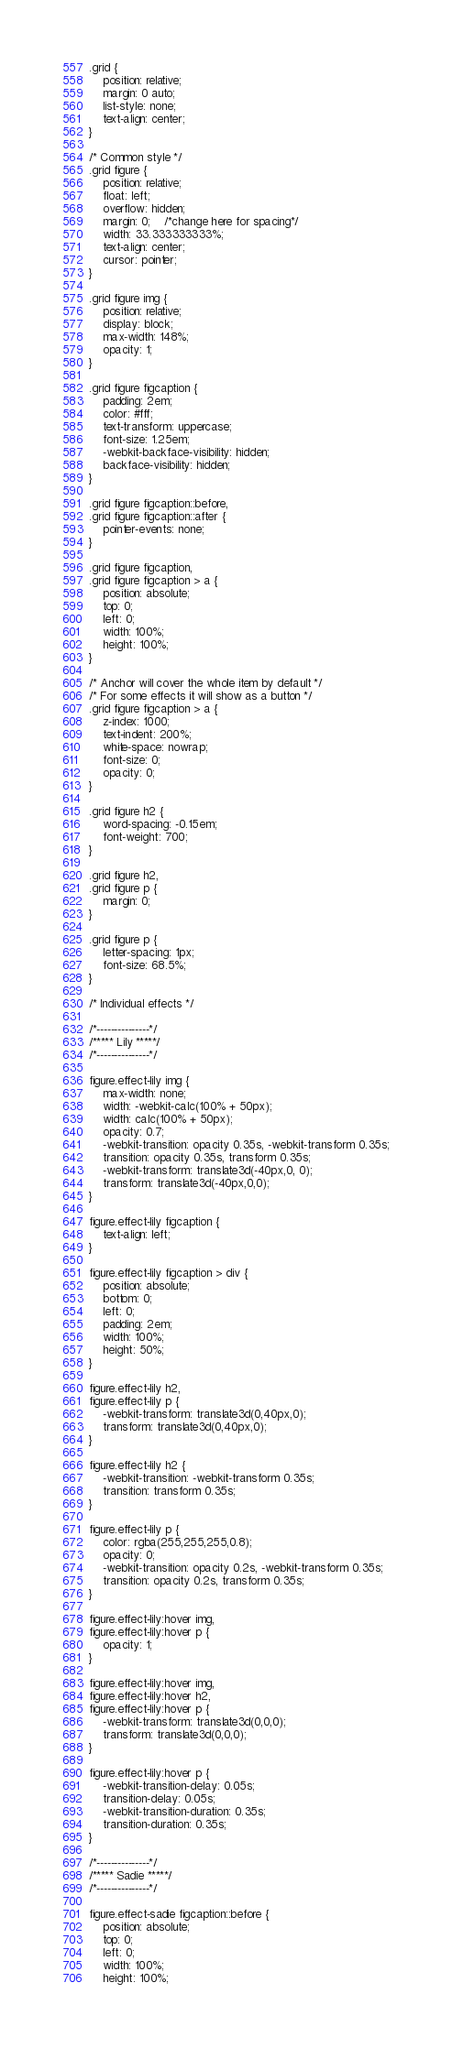<code> <loc_0><loc_0><loc_500><loc_500><_CSS_>.grid {
	position: relative;
	margin: 0 auto;
	list-style: none;
	text-align: center;
}

/* Common style */
.grid figure {
	position: relative;
	float: left;
	overflow: hidden;
	margin: 0;	/*change here for spacing*/	
	width: 33.333333333%;
	text-align: center;
	cursor: pointer;
}

.grid figure img {
	position: relative;
	display: block;
	max-width: 148%;
	opacity: 1;
}

.grid figure figcaption {
	padding: 2em;
	color: #fff;
	text-transform: uppercase;
	font-size: 1.25em;
	-webkit-backface-visibility: hidden;
	backface-visibility: hidden;
}

.grid figure figcaption::before,
.grid figure figcaption::after {
	pointer-events: none;
}

.grid figure figcaption,
.grid figure figcaption > a {
	position: absolute;
	top: 0;
	left: 0;
	width: 100%;
	height: 100%;
}

/* Anchor will cover the whole item by default */
/* For some effects it will show as a button */
.grid figure figcaption > a {
	z-index: 1000;
	text-indent: 200%;
	white-space: nowrap;
	font-size: 0;
	opacity: 0;
}

.grid figure h2 {
	word-spacing: -0.15em;
	font-weight: 700;
}

.grid figure h2,
.grid figure p {
	margin: 0;
}

.grid figure p {
	letter-spacing: 1px;
	font-size: 68.5%;
}

/* Individual effects */

/*---------------*/
/***** Lily *****/
/*---------------*/

figure.effect-lily img {
	max-width: none;
	width: -webkit-calc(100% + 50px);
	width: calc(100% + 50px);
	opacity: 0.7;
	-webkit-transition: opacity 0.35s, -webkit-transform 0.35s;
	transition: opacity 0.35s, transform 0.35s;
	-webkit-transform: translate3d(-40px,0, 0);
	transform: translate3d(-40px,0,0);
}

figure.effect-lily figcaption {
	text-align: left;
}

figure.effect-lily figcaption > div {
	position: absolute;
	bottom: 0;
	left: 0;
	padding: 2em;
	width: 100%;
	height: 50%;
}

figure.effect-lily h2,
figure.effect-lily p {
	-webkit-transform: translate3d(0,40px,0);
	transform: translate3d(0,40px,0);
}

figure.effect-lily h2 {
	-webkit-transition: -webkit-transform 0.35s;
	transition: transform 0.35s;
}

figure.effect-lily p {
	color: rgba(255,255,255,0.8);
	opacity: 0;
	-webkit-transition: opacity 0.2s, -webkit-transform 0.35s;
	transition: opacity 0.2s, transform 0.35s;
}

figure.effect-lily:hover img,
figure.effect-lily:hover p {
	opacity: 1;
}

figure.effect-lily:hover img,
figure.effect-lily:hover h2,
figure.effect-lily:hover p {
	-webkit-transform: translate3d(0,0,0);
	transform: translate3d(0,0,0);
}

figure.effect-lily:hover p {
	-webkit-transition-delay: 0.05s;
	transition-delay: 0.05s;
	-webkit-transition-duration: 0.35s;
	transition-duration: 0.35s;
}

/*---------------*/
/***** Sadie *****/
/*---------------*/

figure.effect-sadie figcaption::before {
	position: absolute;
	top: 0;
	left: 0;
	width: 100%;
	height: 100%;</code> 